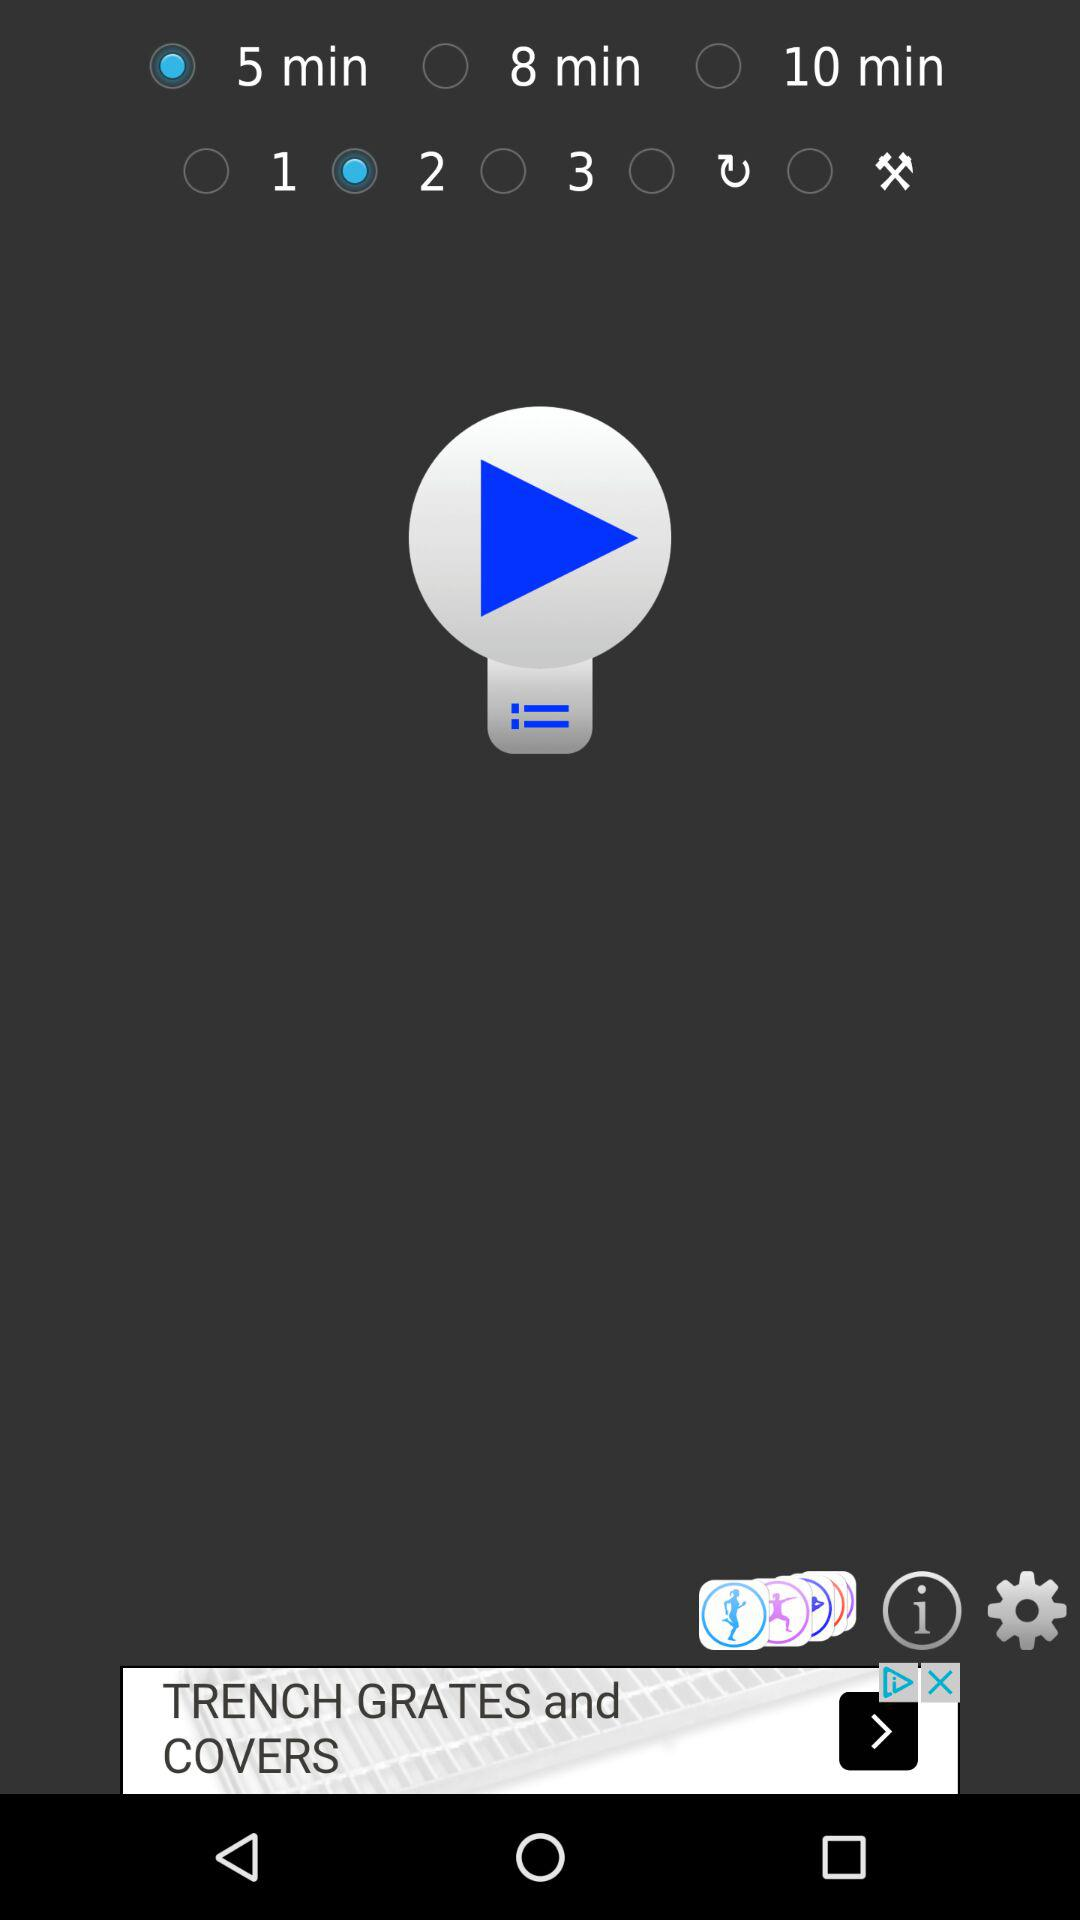Which option is selected? The selected options are "5 min" and "2". 